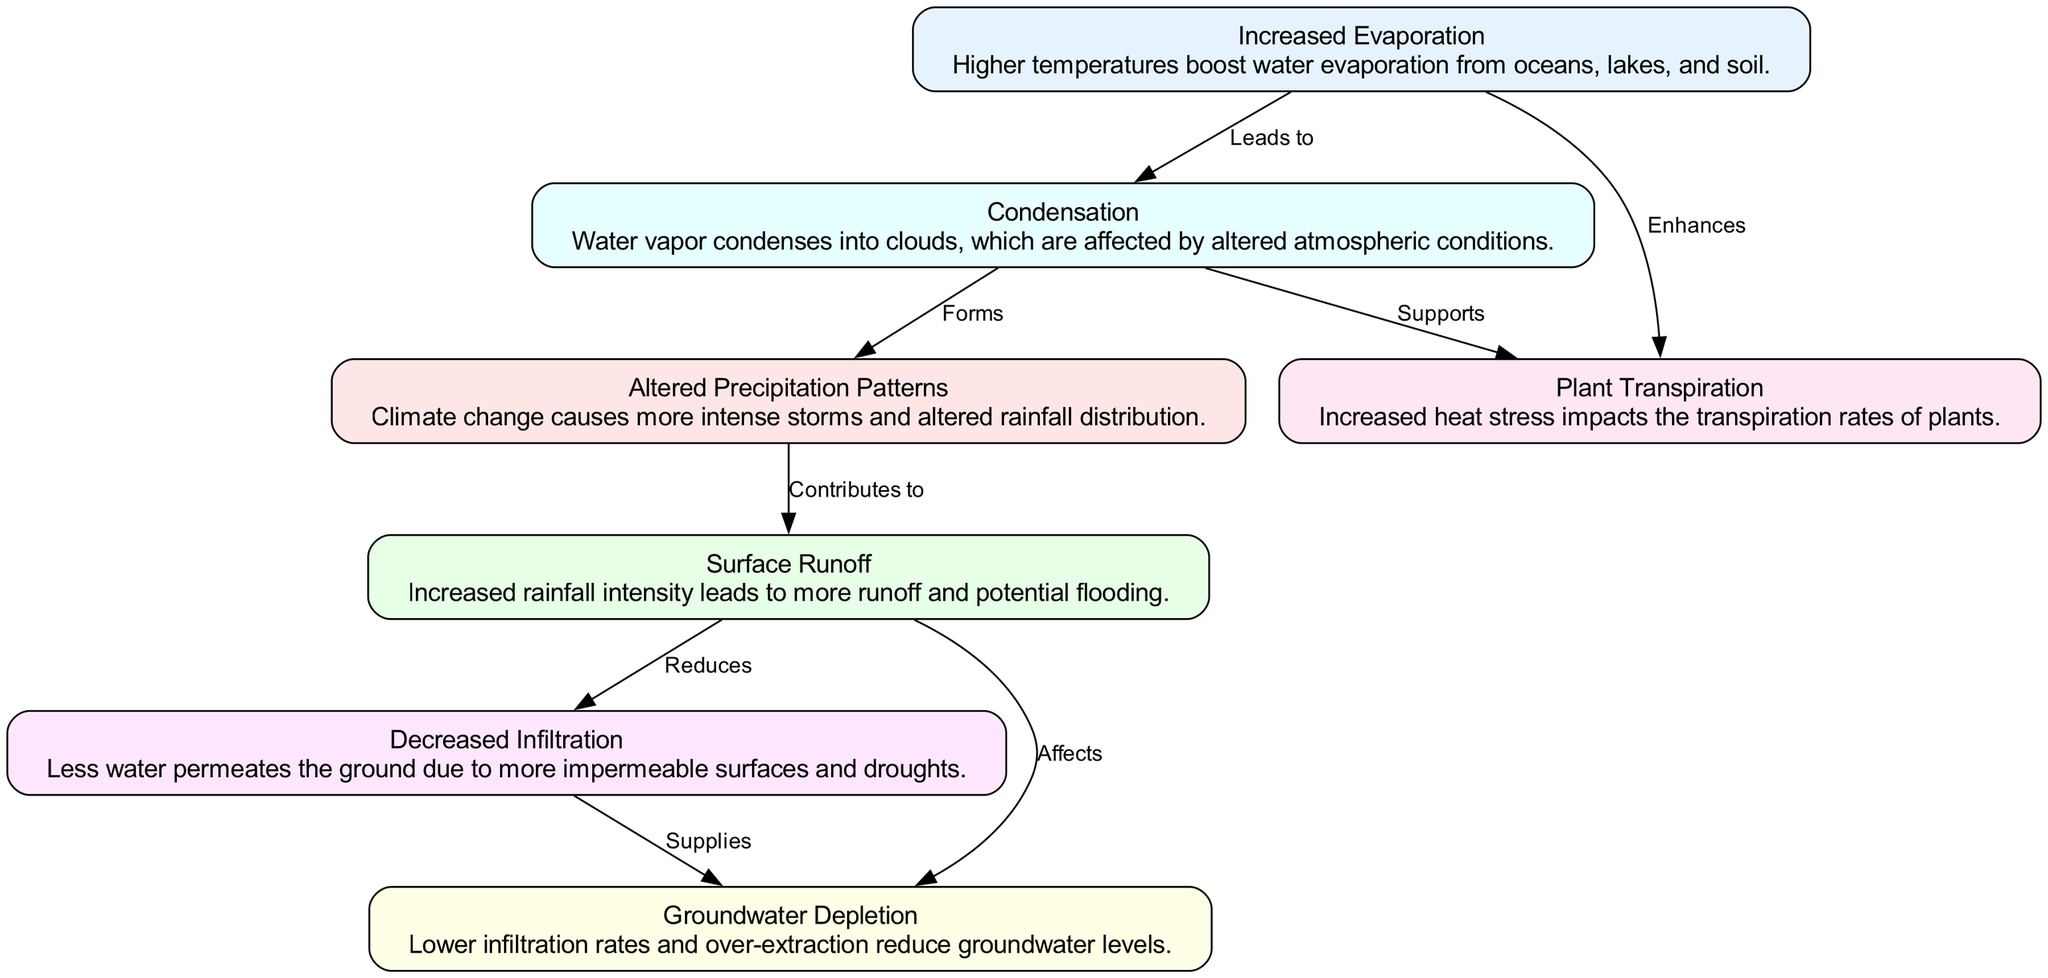What are the main components of the water cycle depicted in the diagram? The diagram lists six main components: Increased Evaporation, Altered Precipitation Patterns, Surface Runoff, Decreased Infiltration, Groundwater Depletion, and Plant Transpiration. These components represent the stages and processes of the water cycle.
Answer: Increased Evaporation, Altered Precipitation Patterns, Surface Runoff, Decreased Infiltration, Groundwater Depletion, Plant Transpiration How many nodes are there in the diagram? The diagram contains a total of seven nodes, each representing a distinct process in the water cycle.
Answer: Seven What does increased evaporation lead to according to the diagram? The diagram indicates that increased evaporation leads to condensation. This shows the sequential flow from evaporation to the formation of clouds.
Answer: Condensation How does runoff affect infiltration? The diagram states that runoff reduces infiltration. This relationship indicates that increased surface runoff can lead to less water permeating into the ground.
Answer: Reduces What happens to groundwater levels due to decreased infiltration? The diagram shows that decreased infiltration supplies less water to groundwater, leading to groundwater depletion. This relationship highlights the impact of reduced infiltration on groundwater resources.
Answer: Groundwater Depletion Which node supports plant transpiration? According to the diagram, condensation supports plant transpiration. This demonstrates the interdependence of these processes in the water cycle, where cloud formation aids plant water absorption.
Answer: Condensation How many edges connect the nodes in the diagram? The diagram contains seven edges, indicating the relationships between different components of the water cycle and depicting how they influence each other.
Answer: Seven What impact does climate change have on precipitation patterns? The diagram illustrates that climate change causes altered precipitation patterns, implying changes in rainfall distribution and intensity due to increasing global temperatures.
Answer: Altered Precipitation Patterns What is the relationship between runoff and groundwater according to the diagram? The diagram indicates that runoff affects groundwater, particularly showing that increased runoff can negatively impact groundwater levels due to reduced water infiltration.
Answer: Affects 